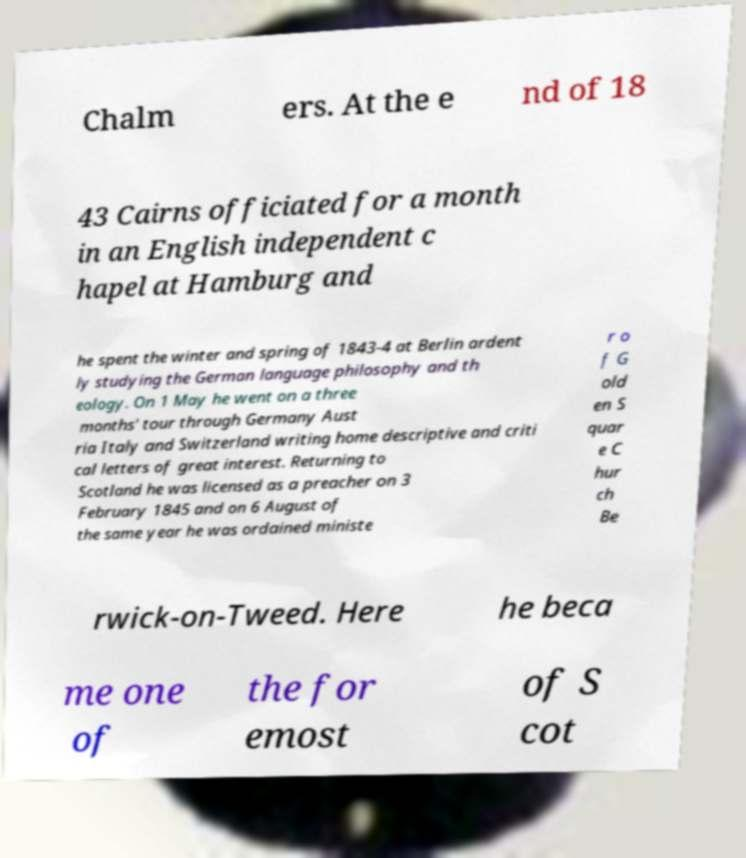I need the written content from this picture converted into text. Can you do that? Chalm ers. At the e nd of 18 43 Cairns officiated for a month in an English independent c hapel at Hamburg and he spent the winter and spring of 1843-4 at Berlin ardent ly studying the German language philosophy and th eology. On 1 May he went on a three months' tour through Germany Aust ria Italy and Switzerland writing home descriptive and criti cal letters of great interest. Returning to Scotland he was licensed as a preacher on 3 February 1845 and on 6 August of the same year he was ordained ministe r o f G old en S quar e C hur ch Be rwick-on-Tweed. Here he beca me one of the for emost of S cot 